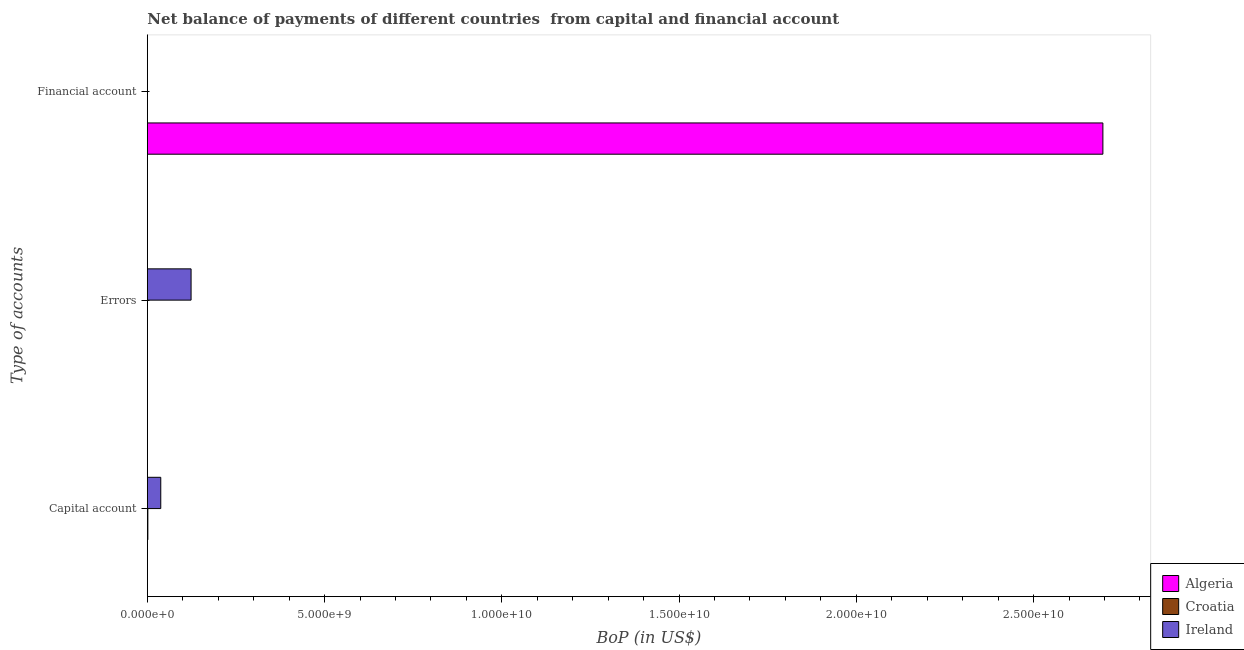How many different coloured bars are there?
Keep it short and to the point. 3. Are the number of bars per tick equal to the number of legend labels?
Your answer should be very brief. No. Are the number of bars on each tick of the Y-axis equal?
Provide a succinct answer. No. How many bars are there on the 2nd tick from the top?
Keep it short and to the point. 1. How many bars are there on the 3rd tick from the bottom?
Your response must be concise. 1. What is the label of the 1st group of bars from the top?
Provide a short and direct response. Financial account. What is the amount of errors in Croatia?
Offer a terse response. 0. Across all countries, what is the maximum amount of financial account?
Provide a short and direct response. 2.70e+1. Across all countries, what is the minimum amount of errors?
Ensure brevity in your answer.  0. In which country was the amount of net capital account maximum?
Offer a terse response. Ireland. What is the total amount of net capital account in the graph?
Your answer should be very brief. 3.93e+08. What is the difference between the amount of net capital account in Algeria and the amount of errors in Ireland?
Provide a short and direct response. -1.23e+09. What is the average amount of financial account per country?
Your answer should be very brief. 8.99e+09. What is the difference between the amount of net capital account and amount of errors in Ireland?
Your answer should be compact. -8.55e+08. What is the ratio of the amount of net capital account in Ireland to that in Croatia?
Give a very brief answer. 25.69. What is the difference between the highest and the lowest amount of net capital account?
Make the answer very short. 3.79e+08. Is it the case that in every country, the sum of the amount of net capital account and amount of errors is greater than the amount of financial account?
Your answer should be compact. No. How many bars are there?
Make the answer very short. 4. Are all the bars in the graph horizontal?
Provide a succinct answer. Yes. Are the values on the major ticks of X-axis written in scientific E-notation?
Offer a terse response. Yes. Does the graph contain grids?
Your response must be concise. No. Where does the legend appear in the graph?
Keep it short and to the point. Bottom right. How are the legend labels stacked?
Your response must be concise. Vertical. What is the title of the graph?
Keep it short and to the point. Net balance of payments of different countries  from capital and financial account. Does "Ecuador" appear as one of the legend labels in the graph?
Keep it short and to the point. No. What is the label or title of the X-axis?
Offer a terse response. BoP (in US$). What is the label or title of the Y-axis?
Ensure brevity in your answer.  Type of accounts. What is the BoP (in US$) of Croatia in Capital account?
Provide a succinct answer. 1.47e+07. What is the BoP (in US$) in Ireland in Capital account?
Keep it short and to the point. 3.79e+08. What is the BoP (in US$) in Algeria in Errors?
Give a very brief answer. 0. What is the BoP (in US$) in Croatia in Errors?
Keep it short and to the point. 0. What is the BoP (in US$) of Ireland in Errors?
Give a very brief answer. 1.23e+09. What is the BoP (in US$) in Algeria in Financial account?
Your answer should be compact. 2.70e+1. Across all Type of accounts, what is the maximum BoP (in US$) in Algeria?
Provide a succinct answer. 2.70e+1. Across all Type of accounts, what is the maximum BoP (in US$) in Croatia?
Your response must be concise. 1.47e+07. Across all Type of accounts, what is the maximum BoP (in US$) in Ireland?
Your answer should be compact. 1.23e+09. What is the total BoP (in US$) in Algeria in the graph?
Offer a very short reply. 2.70e+1. What is the total BoP (in US$) of Croatia in the graph?
Make the answer very short. 1.47e+07. What is the total BoP (in US$) in Ireland in the graph?
Ensure brevity in your answer.  1.61e+09. What is the difference between the BoP (in US$) of Ireland in Capital account and that in Errors?
Provide a short and direct response. -8.55e+08. What is the difference between the BoP (in US$) of Croatia in Capital account and the BoP (in US$) of Ireland in Errors?
Give a very brief answer. -1.22e+09. What is the average BoP (in US$) of Algeria per Type of accounts?
Your answer should be very brief. 8.99e+09. What is the average BoP (in US$) in Croatia per Type of accounts?
Your answer should be compact. 4.91e+06. What is the average BoP (in US$) in Ireland per Type of accounts?
Ensure brevity in your answer.  5.37e+08. What is the difference between the BoP (in US$) of Croatia and BoP (in US$) of Ireland in Capital account?
Give a very brief answer. -3.64e+08. What is the ratio of the BoP (in US$) in Ireland in Capital account to that in Errors?
Give a very brief answer. 0.31. What is the difference between the highest and the lowest BoP (in US$) in Algeria?
Provide a succinct answer. 2.70e+1. What is the difference between the highest and the lowest BoP (in US$) in Croatia?
Make the answer very short. 1.47e+07. What is the difference between the highest and the lowest BoP (in US$) of Ireland?
Your answer should be very brief. 1.23e+09. 